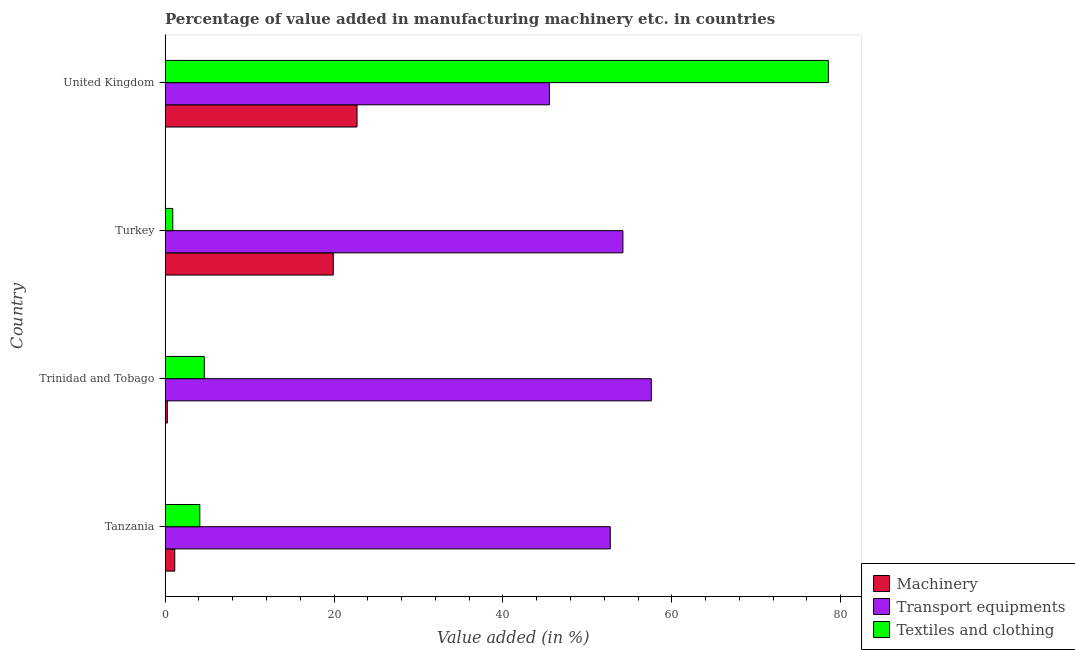Are the number of bars per tick equal to the number of legend labels?
Offer a terse response. Yes. How many bars are there on the 3rd tick from the top?
Your response must be concise. 3. What is the label of the 2nd group of bars from the top?
Your response must be concise. Turkey. In how many cases, is the number of bars for a given country not equal to the number of legend labels?
Your answer should be compact. 0. What is the value added in manufacturing textile and clothing in United Kingdom?
Ensure brevity in your answer.  78.54. Across all countries, what is the maximum value added in manufacturing machinery?
Provide a succinct answer. 22.73. Across all countries, what is the minimum value added in manufacturing machinery?
Provide a short and direct response. 0.27. In which country was the value added in manufacturing transport equipments minimum?
Offer a very short reply. United Kingdom. What is the total value added in manufacturing machinery in the graph?
Your response must be concise. 44.05. What is the difference between the value added in manufacturing textile and clothing in Trinidad and Tobago and that in United Kingdom?
Offer a terse response. -73.9. What is the difference between the value added in manufacturing machinery in Turkey and the value added in manufacturing textile and clothing in Trinidad and Tobago?
Your answer should be compact. 15.27. What is the average value added in manufacturing transport equipments per country?
Offer a terse response. 52.5. What is the difference between the value added in manufacturing transport equipments and value added in manufacturing machinery in Trinidad and Tobago?
Your response must be concise. 57.3. What is the ratio of the value added in manufacturing textile and clothing in Turkey to that in United Kingdom?
Give a very brief answer. 0.01. What is the difference between the highest and the second highest value added in manufacturing machinery?
Make the answer very short. 2.81. What is the difference between the highest and the lowest value added in manufacturing machinery?
Keep it short and to the point. 22.46. In how many countries, is the value added in manufacturing machinery greater than the average value added in manufacturing machinery taken over all countries?
Offer a terse response. 2. What does the 3rd bar from the top in Trinidad and Tobago represents?
Provide a succinct answer. Machinery. What does the 1st bar from the bottom in Tanzania represents?
Make the answer very short. Machinery. Are all the bars in the graph horizontal?
Your answer should be very brief. Yes. Are the values on the major ticks of X-axis written in scientific E-notation?
Your answer should be compact. No. How many legend labels are there?
Your answer should be very brief. 3. What is the title of the graph?
Your response must be concise. Percentage of value added in manufacturing machinery etc. in countries. Does "Travel services" appear as one of the legend labels in the graph?
Offer a very short reply. No. What is the label or title of the X-axis?
Your answer should be very brief. Value added (in %). What is the label or title of the Y-axis?
Offer a very short reply. Country. What is the Value added (in %) in Machinery in Tanzania?
Offer a terse response. 1.14. What is the Value added (in %) of Transport equipments in Tanzania?
Provide a succinct answer. 52.71. What is the Value added (in %) in Textiles and clothing in Tanzania?
Ensure brevity in your answer.  4.11. What is the Value added (in %) of Machinery in Trinidad and Tobago?
Provide a succinct answer. 0.27. What is the Value added (in %) of Transport equipments in Trinidad and Tobago?
Ensure brevity in your answer.  57.57. What is the Value added (in %) of Textiles and clothing in Trinidad and Tobago?
Your answer should be very brief. 4.64. What is the Value added (in %) of Machinery in Turkey?
Provide a short and direct response. 19.91. What is the Value added (in %) of Transport equipments in Turkey?
Your answer should be very brief. 54.21. What is the Value added (in %) in Textiles and clothing in Turkey?
Your response must be concise. 0.91. What is the Value added (in %) of Machinery in United Kingdom?
Keep it short and to the point. 22.73. What is the Value added (in %) of Transport equipments in United Kingdom?
Your answer should be very brief. 45.51. What is the Value added (in %) in Textiles and clothing in United Kingdom?
Your answer should be very brief. 78.54. Across all countries, what is the maximum Value added (in %) of Machinery?
Offer a very short reply. 22.73. Across all countries, what is the maximum Value added (in %) of Transport equipments?
Keep it short and to the point. 57.57. Across all countries, what is the maximum Value added (in %) of Textiles and clothing?
Your answer should be compact. 78.54. Across all countries, what is the minimum Value added (in %) in Machinery?
Provide a succinct answer. 0.27. Across all countries, what is the minimum Value added (in %) in Transport equipments?
Offer a very short reply. 45.51. Across all countries, what is the minimum Value added (in %) of Textiles and clothing?
Your response must be concise. 0.91. What is the total Value added (in %) in Machinery in the graph?
Offer a very short reply. 44.05. What is the total Value added (in %) in Transport equipments in the graph?
Give a very brief answer. 210. What is the total Value added (in %) in Textiles and clothing in the graph?
Provide a short and direct response. 88.2. What is the difference between the Value added (in %) of Machinery in Tanzania and that in Trinidad and Tobago?
Your answer should be very brief. 0.88. What is the difference between the Value added (in %) of Transport equipments in Tanzania and that in Trinidad and Tobago?
Provide a succinct answer. -4.86. What is the difference between the Value added (in %) in Textiles and clothing in Tanzania and that in Trinidad and Tobago?
Your answer should be compact. -0.53. What is the difference between the Value added (in %) of Machinery in Tanzania and that in Turkey?
Provide a succinct answer. -18.77. What is the difference between the Value added (in %) of Transport equipments in Tanzania and that in Turkey?
Provide a succinct answer. -1.5. What is the difference between the Value added (in %) in Textiles and clothing in Tanzania and that in Turkey?
Keep it short and to the point. 3.2. What is the difference between the Value added (in %) in Machinery in Tanzania and that in United Kingdom?
Make the answer very short. -21.58. What is the difference between the Value added (in %) in Transport equipments in Tanzania and that in United Kingdom?
Make the answer very short. 7.21. What is the difference between the Value added (in %) of Textiles and clothing in Tanzania and that in United Kingdom?
Your answer should be very brief. -74.43. What is the difference between the Value added (in %) in Machinery in Trinidad and Tobago and that in Turkey?
Your answer should be compact. -19.65. What is the difference between the Value added (in %) in Transport equipments in Trinidad and Tobago and that in Turkey?
Provide a short and direct response. 3.36. What is the difference between the Value added (in %) of Textiles and clothing in Trinidad and Tobago and that in Turkey?
Give a very brief answer. 3.73. What is the difference between the Value added (in %) in Machinery in Trinidad and Tobago and that in United Kingdom?
Make the answer very short. -22.46. What is the difference between the Value added (in %) of Transport equipments in Trinidad and Tobago and that in United Kingdom?
Offer a very short reply. 12.06. What is the difference between the Value added (in %) of Textiles and clothing in Trinidad and Tobago and that in United Kingdom?
Provide a succinct answer. -73.9. What is the difference between the Value added (in %) of Machinery in Turkey and that in United Kingdom?
Ensure brevity in your answer.  -2.81. What is the difference between the Value added (in %) in Transport equipments in Turkey and that in United Kingdom?
Provide a succinct answer. 8.71. What is the difference between the Value added (in %) of Textiles and clothing in Turkey and that in United Kingdom?
Offer a very short reply. -77.63. What is the difference between the Value added (in %) of Machinery in Tanzania and the Value added (in %) of Transport equipments in Trinidad and Tobago?
Offer a terse response. -56.43. What is the difference between the Value added (in %) of Machinery in Tanzania and the Value added (in %) of Textiles and clothing in Trinidad and Tobago?
Your answer should be compact. -3.5. What is the difference between the Value added (in %) of Transport equipments in Tanzania and the Value added (in %) of Textiles and clothing in Trinidad and Tobago?
Provide a succinct answer. 48.07. What is the difference between the Value added (in %) of Machinery in Tanzania and the Value added (in %) of Transport equipments in Turkey?
Keep it short and to the point. -53.07. What is the difference between the Value added (in %) of Machinery in Tanzania and the Value added (in %) of Textiles and clothing in Turkey?
Ensure brevity in your answer.  0.23. What is the difference between the Value added (in %) of Transport equipments in Tanzania and the Value added (in %) of Textiles and clothing in Turkey?
Ensure brevity in your answer.  51.8. What is the difference between the Value added (in %) of Machinery in Tanzania and the Value added (in %) of Transport equipments in United Kingdom?
Ensure brevity in your answer.  -44.36. What is the difference between the Value added (in %) in Machinery in Tanzania and the Value added (in %) in Textiles and clothing in United Kingdom?
Your response must be concise. -77.39. What is the difference between the Value added (in %) of Transport equipments in Tanzania and the Value added (in %) of Textiles and clothing in United Kingdom?
Make the answer very short. -25.82. What is the difference between the Value added (in %) of Machinery in Trinidad and Tobago and the Value added (in %) of Transport equipments in Turkey?
Provide a succinct answer. -53.95. What is the difference between the Value added (in %) in Machinery in Trinidad and Tobago and the Value added (in %) in Textiles and clothing in Turkey?
Provide a succinct answer. -0.64. What is the difference between the Value added (in %) of Transport equipments in Trinidad and Tobago and the Value added (in %) of Textiles and clothing in Turkey?
Give a very brief answer. 56.66. What is the difference between the Value added (in %) in Machinery in Trinidad and Tobago and the Value added (in %) in Transport equipments in United Kingdom?
Your answer should be compact. -45.24. What is the difference between the Value added (in %) in Machinery in Trinidad and Tobago and the Value added (in %) in Textiles and clothing in United Kingdom?
Your response must be concise. -78.27. What is the difference between the Value added (in %) of Transport equipments in Trinidad and Tobago and the Value added (in %) of Textiles and clothing in United Kingdom?
Give a very brief answer. -20.97. What is the difference between the Value added (in %) of Machinery in Turkey and the Value added (in %) of Transport equipments in United Kingdom?
Your answer should be very brief. -25.59. What is the difference between the Value added (in %) of Machinery in Turkey and the Value added (in %) of Textiles and clothing in United Kingdom?
Your response must be concise. -58.63. What is the difference between the Value added (in %) of Transport equipments in Turkey and the Value added (in %) of Textiles and clothing in United Kingdom?
Provide a short and direct response. -24.33. What is the average Value added (in %) of Machinery per country?
Keep it short and to the point. 11.01. What is the average Value added (in %) of Transport equipments per country?
Offer a terse response. 52.5. What is the average Value added (in %) of Textiles and clothing per country?
Keep it short and to the point. 22.05. What is the difference between the Value added (in %) in Machinery and Value added (in %) in Transport equipments in Tanzania?
Offer a terse response. -51.57. What is the difference between the Value added (in %) in Machinery and Value added (in %) in Textiles and clothing in Tanzania?
Keep it short and to the point. -2.97. What is the difference between the Value added (in %) in Transport equipments and Value added (in %) in Textiles and clothing in Tanzania?
Provide a short and direct response. 48.6. What is the difference between the Value added (in %) in Machinery and Value added (in %) in Transport equipments in Trinidad and Tobago?
Keep it short and to the point. -57.3. What is the difference between the Value added (in %) in Machinery and Value added (in %) in Textiles and clothing in Trinidad and Tobago?
Give a very brief answer. -4.38. What is the difference between the Value added (in %) of Transport equipments and Value added (in %) of Textiles and clothing in Trinidad and Tobago?
Your answer should be very brief. 52.93. What is the difference between the Value added (in %) in Machinery and Value added (in %) in Transport equipments in Turkey?
Make the answer very short. -34.3. What is the difference between the Value added (in %) of Machinery and Value added (in %) of Textiles and clothing in Turkey?
Keep it short and to the point. 19. What is the difference between the Value added (in %) of Transport equipments and Value added (in %) of Textiles and clothing in Turkey?
Make the answer very short. 53.3. What is the difference between the Value added (in %) in Machinery and Value added (in %) in Transport equipments in United Kingdom?
Offer a terse response. -22.78. What is the difference between the Value added (in %) of Machinery and Value added (in %) of Textiles and clothing in United Kingdom?
Keep it short and to the point. -55.81. What is the difference between the Value added (in %) of Transport equipments and Value added (in %) of Textiles and clothing in United Kingdom?
Make the answer very short. -33.03. What is the ratio of the Value added (in %) of Machinery in Tanzania to that in Trinidad and Tobago?
Your answer should be very brief. 4.3. What is the ratio of the Value added (in %) of Transport equipments in Tanzania to that in Trinidad and Tobago?
Offer a terse response. 0.92. What is the ratio of the Value added (in %) in Textiles and clothing in Tanzania to that in Trinidad and Tobago?
Provide a short and direct response. 0.89. What is the ratio of the Value added (in %) of Machinery in Tanzania to that in Turkey?
Your answer should be very brief. 0.06. What is the ratio of the Value added (in %) in Transport equipments in Tanzania to that in Turkey?
Ensure brevity in your answer.  0.97. What is the ratio of the Value added (in %) in Textiles and clothing in Tanzania to that in Turkey?
Make the answer very short. 4.52. What is the ratio of the Value added (in %) in Machinery in Tanzania to that in United Kingdom?
Keep it short and to the point. 0.05. What is the ratio of the Value added (in %) in Transport equipments in Tanzania to that in United Kingdom?
Your answer should be compact. 1.16. What is the ratio of the Value added (in %) of Textiles and clothing in Tanzania to that in United Kingdom?
Your answer should be very brief. 0.05. What is the ratio of the Value added (in %) of Machinery in Trinidad and Tobago to that in Turkey?
Keep it short and to the point. 0.01. What is the ratio of the Value added (in %) of Transport equipments in Trinidad and Tobago to that in Turkey?
Keep it short and to the point. 1.06. What is the ratio of the Value added (in %) in Textiles and clothing in Trinidad and Tobago to that in Turkey?
Your response must be concise. 5.1. What is the ratio of the Value added (in %) of Machinery in Trinidad and Tobago to that in United Kingdom?
Offer a terse response. 0.01. What is the ratio of the Value added (in %) in Transport equipments in Trinidad and Tobago to that in United Kingdom?
Offer a very short reply. 1.27. What is the ratio of the Value added (in %) of Textiles and clothing in Trinidad and Tobago to that in United Kingdom?
Provide a short and direct response. 0.06. What is the ratio of the Value added (in %) of Machinery in Turkey to that in United Kingdom?
Your answer should be compact. 0.88. What is the ratio of the Value added (in %) in Transport equipments in Turkey to that in United Kingdom?
Provide a succinct answer. 1.19. What is the ratio of the Value added (in %) in Textiles and clothing in Turkey to that in United Kingdom?
Provide a short and direct response. 0.01. What is the difference between the highest and the second highest Value added (in %) in Machinery?
Give a very brief answer. 2.81. What is the difference between the highest and the second highest Value added (in %) in Transport equipments?
Your response must be concise. 3.36. What is the difference between the highest and the second highest Value added (in %) in Textiles and clothing?
Provide a short and direct response. 73.9. What is the difference between the highest and the lowest Value added (in %) of Machinery?
Ensure brevity in your answer.  22.46. What is the difference between the highest and the lowest Value added (in %) of Transport equipments?
Your answer should be very brief. 12.06. What is the difference between the highest and the lowest Value added (in %) in Textiles and clothing?
Offer a very short reply. 77.63. 